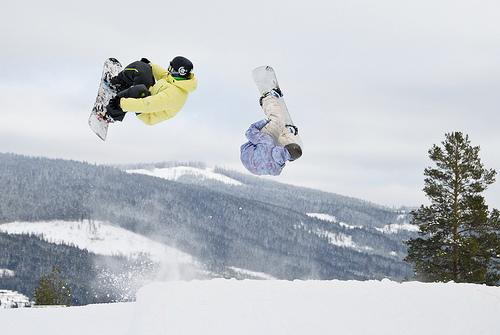What type of landscape is the image set in and what are the weather conditions that can be inferred? The landscape is a snowy, mountainous terrain with trees, suggesting a cold winter day with possible cloud cover in the sky. What is the approximate position of the snowboarders in relation to the ground and the trees? The snowboarders are above the ground and the hill, and in front of the trees on the mountain side. How many snowboarders are there in the image and what are the colors of their jackets? There are two snowboarders. One is wearing a yellow jacket and the other is wearing a blue and purple jacket. Describe the key objects and elements of the image in a concise manner. The image features two airborne snowboarders performing tricks, dressed in colorful jackets and black pants, with a snowy landscape, trees, and mountains as the backdrop. Are there any trees in the image and if so, provide some details about them. Yes, there are trees, including a big pine tree with needles, and other trees in the distance on the snow-covered hill. Give a brief summary of the main activity occurring in this image. The image captures two snowboarders in the air, both upside down, performing tricks over a snowy hill with trees and mountains in the background. Based on the activities shown in the image, indicate the level of expertise of the individuals involved. The snowboarders appear to be skilled or experienced, as they are able to perform complex aerial tricks. What is the background of the image composed of, and how does it set the scene? The background consists of a hill covered in trees and snow, mountains, and a sky with cloud cover, creating a winter scenery for the snowboarding activity. What are the two main pieces of clothing being worn by the snowboarders and their colors? The snowboarders are wearing jackets and pants. One snowboarder's jacket is yellow, while the other's is blue and purple. Both have black pants. Identify the primary action taking place in the image. Two snowboarders are performing aerial tricks while snowboarding on a snowy hill. 